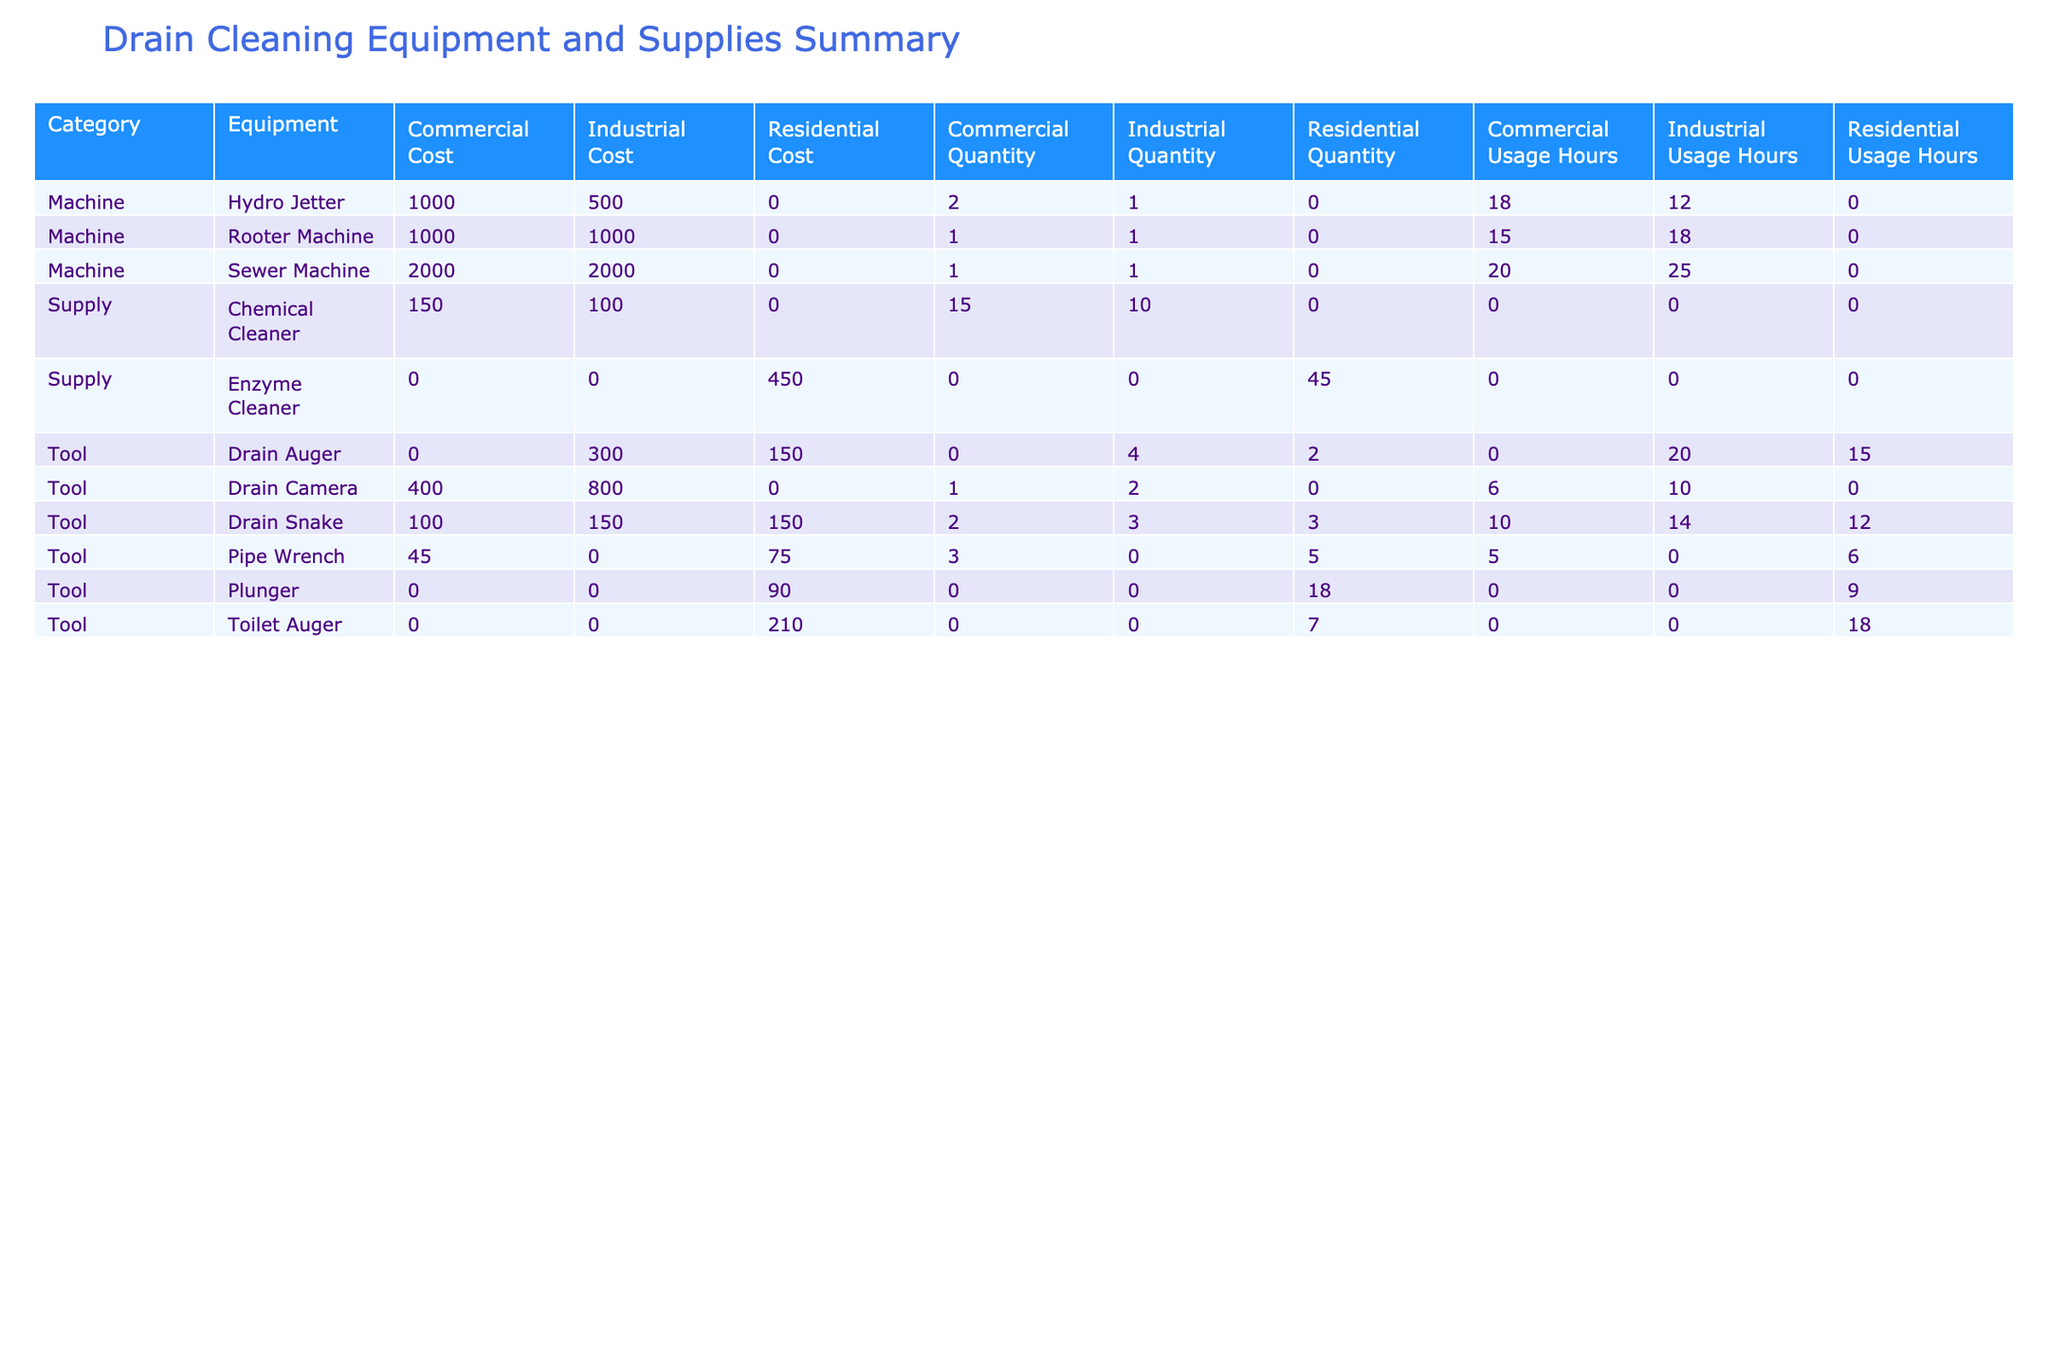What is the total usage hours for the Hydro Jetter across all job types? To find the total usage hours for the Hydro Jetter, we search for all entries under the "Hydro Jetter" equipment in the table. The total usage hours across job types are 8 (commercial) + 12 (industrial) + 10 (commercial) = 30.
Answer: 30 Which equipment had the highest total cost for industrial jobs? Looking at the table, we check the cost entries specifically under the "Industrial" job type. The Sewer Machine cost is 2000, the Drain Camera costs 800, the Rooter Machine costs 1000, and the Drain Auger costs 300. The highest of these is the Sewer Machine at 2000.
Answer: 2000 How many total drain snakes were used in residential jobs? We look for all entries under the "Drain Snake" equipment for the "Residential" job type. The table shows 3 (from July) + 2 (from December) + 3 (from June) = 8.
Answer: 8 Is it true that the Chemical Cleaner was used in any residential jobs? We can verify if Chemical Cleaner appears under the "Residential" job type in the table. Since all entries for Chemical Cleaner are listed under the "Commercial" and "Industrial" categories, the answer is no.
Answer: No What is the average cost of tools used for residential jobs? First, we identify all tools used for residential jobs and their costs: Drain Snake (150), Plunger (50), Pipe Wrench (75), Toilet Auger (90), and Drain Auger (150). The sum of these costs is 150 + 50 + 75 + 90 + 150 = 515 and we have 5 data points. The average cost is 515 / 5 = 103.
Answer: 103 Which job type utilized the highest quantity of supplies? We focus on the "Supply" category and sum the quantities per job type. Here we have Enzyme Cleaner (20 residential), Chemical Cleaner (15 commercial), and another Enzyme Cleaner (25 residential), totaling 20 + 15 + 25 = 60 residential and 15 commercial. The highest quantity was in residential.
Answer: Residential How many drain cameras were used in total, and what was their total cost? To find this, we locate all entries under "Drain Camera." There's one used in August with a quantity of 2 and cost of 800 (industrial) and another in February with a quantity of 1 and cost of 400 (commercial). Therefore, the total quantity is 2 + 1 = 3 and total cost is 800 + 400 = 1200.
Answer: 3 and 1200 